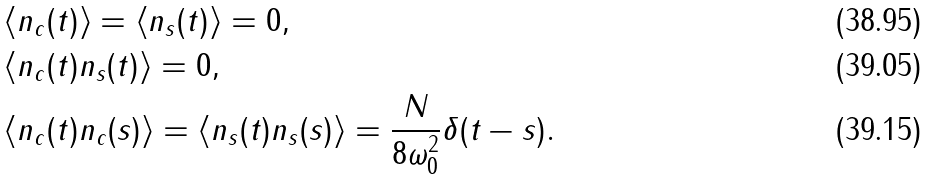<formula> <loc_0><loc_0><loc_500><loc_500>& \left < n _ { c } ( t ) \right > = \left < n _ { s } ( t ) \right > = 0 , \\ & \left < n _ { c } ( t ) n _ { s } ( t ) \right > = 0 , \\ & \left < n _ { c } ( t ) n _ { c } ( s ) \right > = \left < n _ { s } ( t ) n _ { s } ( s ) \right > = \frac { N } { 8 \omega _ { 0 } ^ { 2 } } \delta ( t - s ) .</formula> 